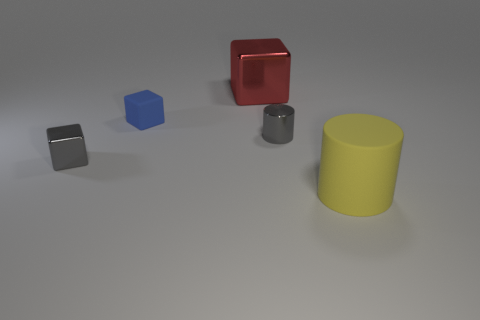Is the color of the small cylinder the same as the tiny shiny cube?
Provide a succinct answer. Yes. Are there any objects on the right side of the gray cylinder?
Your answer should be very brief. Yes. How big is the red shiny cube?
Offer a very short reply. Large. There is a metallic thing that is the same shape as the yellow rubber thing; what size is it?
Your answer should be very brief. Small. There is a tiny thing that is in front of the gray metallic cylinder; how many small metallic things are on the right side of it?
Ensure brevity in your answer.  1. Is the gray thing that is right of the matte cube made of the same material as the big thing in front of the tiny blue matte thing?
Provide a succinct answer. No. How many small shiny objects have the same shape as the tiny blue matte object?
Keep it short and to the point. 1. What number of other large metallic objects have the same color as the big metallic thing?
Make the answer very short. 0. There is a object to the left of the rubber block; is it the same shape as the blue thing that is behind the small shiny cylinder?
Your answer should be compact. Yes. What number of gray cylinders are to the left of the small gray shiny thing that is in front of the tiny gray object to the right of the tiny gray metal cube?
Offer a very short reply. 0. 